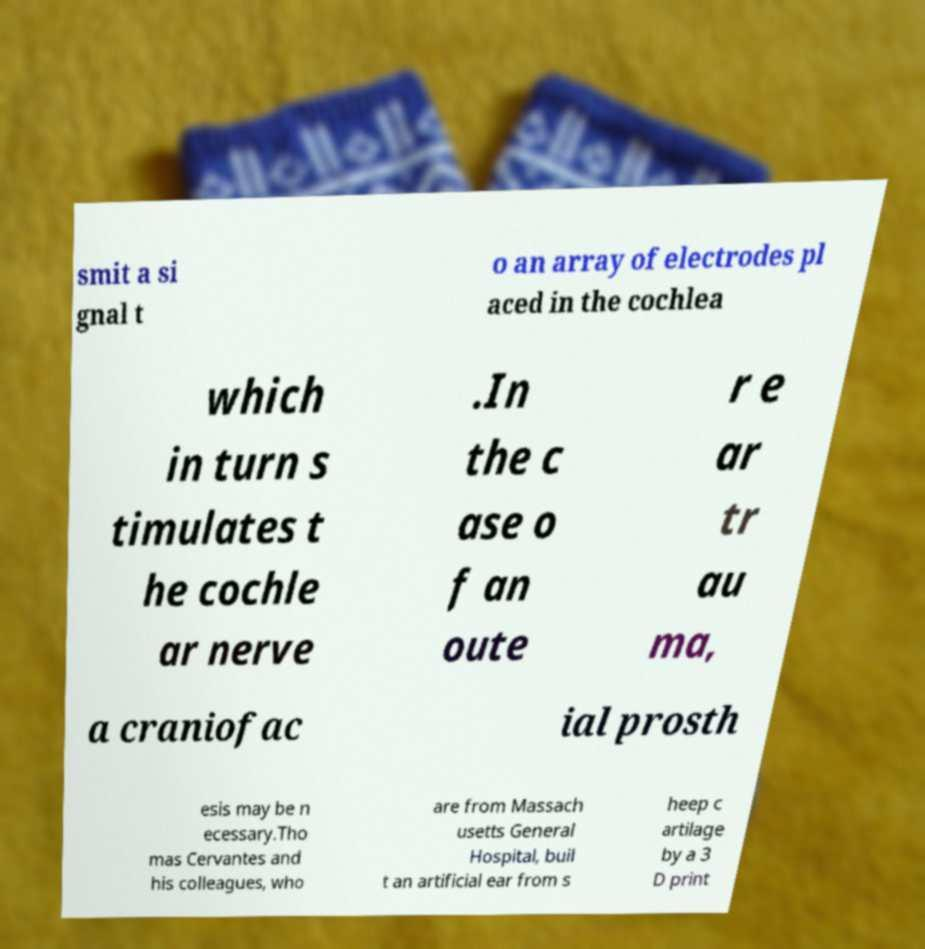Please read and relay the text visible in this image. What does it say? smit a si gnal t o an array of electrodes pl aced in the cochlea which in turn s timulates t he cochle ar nerve .In the c ase o f an oute r e ar tr au ma, a craniofac ial prosth esis may be n ecessary.Tho mas Cervantes and his colleagues, who are from Massach usetts General Hospital, buil t an artificial ear from s heep c artilage by a 3 D print 